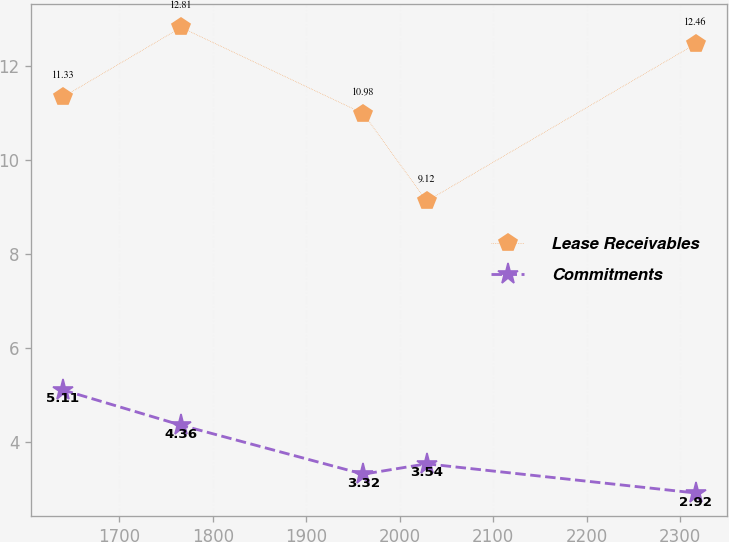<chart> <loc_0><loc_0><loc_500><loc_500><line_chart><ecel><fcel>Lease Receivables<fcel>Commitments<nl><fcel>1639.35<fcel>11.33<fcel>5.11<nl><fcel>1765.95<fcel>12.81<fcel>4.36<nl><fcel>1960.9<fcel>10.98<fcel>3.32<nl><fcel>2028.6<fcel>9.12<fcel>3.54<nl><fcel>2316.35<fcel>12.46<fcel>2.92<nl></chart> 